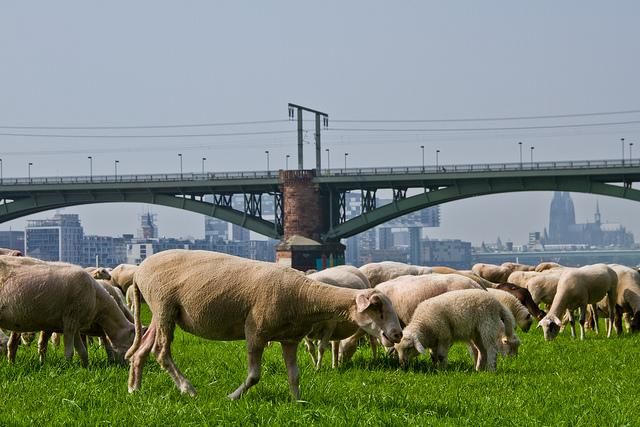What are the animals near? bridge 